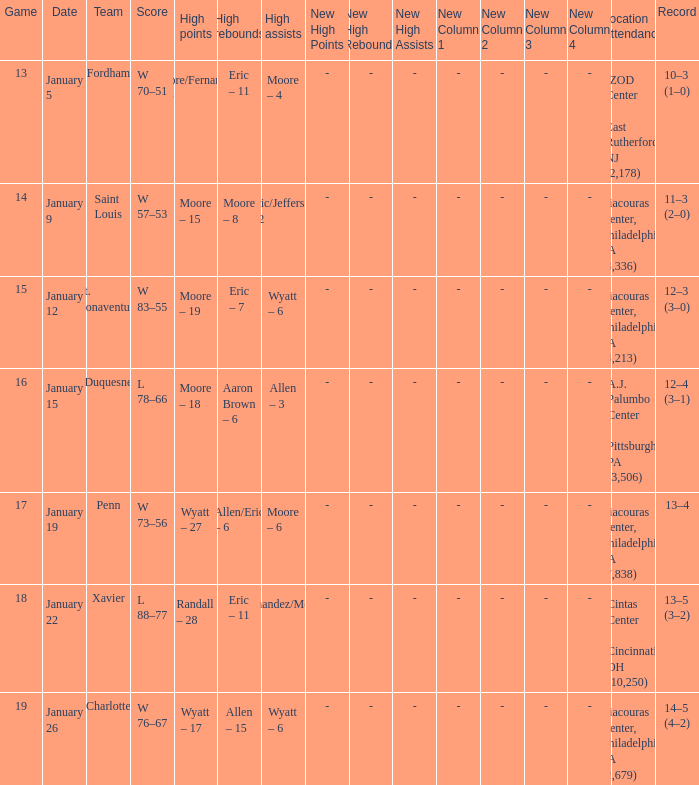What team was Temple playing on January 19? Penn. Help me parse the entirety of this table. {'header': ['Game', 'Date', 'Team', 'Score', 'High points', 'High rebounds', 'High assists', 'New High Points', 'New High Rebounds', 'New High Assists', 'New Column 1', 'New Column 2', 'New Column 3', 'New Column 4', 'Location Attendance', 'Record'], 'rows': [['13', 'January 5', 'Fordham', 'W 70–51', 'Moore/Fernandez – 15', 'Eric – 11', 'Moore – 4', '-', '-', '-', '-', '-', '-', '-', 'IZOD Center , East Rutherford, NJ (2,178)', '10–3 (1–0)'], ['14', 'January 9', 'Saint Louis', 'W 57–53', 'Moore – 15', 'Moore – 8', 'Eric/Jefferson – 2', '-', '-', '-', '-', '-', '-', '-', 'Liacouras Center, Philadelphia, PA (3,336)', '11–3 (2–0)'], ['15', 'January 12', 'St. Bonaventure', 'W 83–55', 'Moore – 19', 'Eric – 7', 'Wyatt – 6', '-', '-', '-', '-', '-', '-', '-', 'Liacouras Center, Philadelphia, PA (3,213)', '12–3 (3–0)'], ['16', 'January 15', 'Duquesne', 'L 78–66', 'Moore – 18', 'Aaron Brown – 6', 'Allen – 3', '-', '-', '-', '-', '-', '-', '-', 'A.J. Palumbo Center , Pittsburgh, PA (3,506)', '12–4 (3–1)'], ['17', 'January 19', 'Penn', 'W 73–56', 'Wyatt – 27', 'Allen/Eric – 6', 'Moore – 6', '-', '-', '-', '-', '-', '-', '-', 'Liacouras Center, Philadelphia, PA (7,838)', '13–4'], ['18', 'January 22', 'Xavier', 'L 88–77', 'Randall – 28', 'Eric – 11', 'Fernandez/Moore – 5', '-', '-', '-', '-', '-', '-', '-', 'Cintas Center , Cincinnati, OH (10,250)', '13–5 (3–2)'], ['19', 'January 26', 'Charlotte', 'W 76–67', 'Wyatt – 17', 'Allen – 15', 'Wyatt – 6', '-', '-', '-', '-', '-', '-', '-', 'Liacouras Center, Philadelphia, PA (2,679)', '14–5 (4–2)']]} 